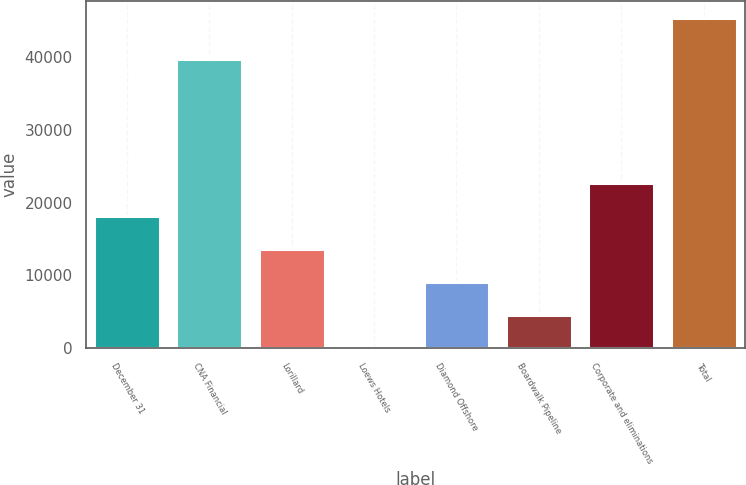Convert chart to OTSL. <chart><loc_0><loc_0><loc_500><loc_500><bar_chart><fcel>December 31<fcel>CNA Financial<fcel>Lorillard<fcel>Loews Hotels<fcel>Diamond Offshore<fcel>Boardwalk Pipeline<fcel>Corporate and eliminations<fcel>Total<nl><fcel>18164.1<fcel>39692.9<fcel>13625.5<fcel>9.5<fcel>9086.8<fcel>4548.15<fcel>22702.8<fcel>45396<nl></chart> 